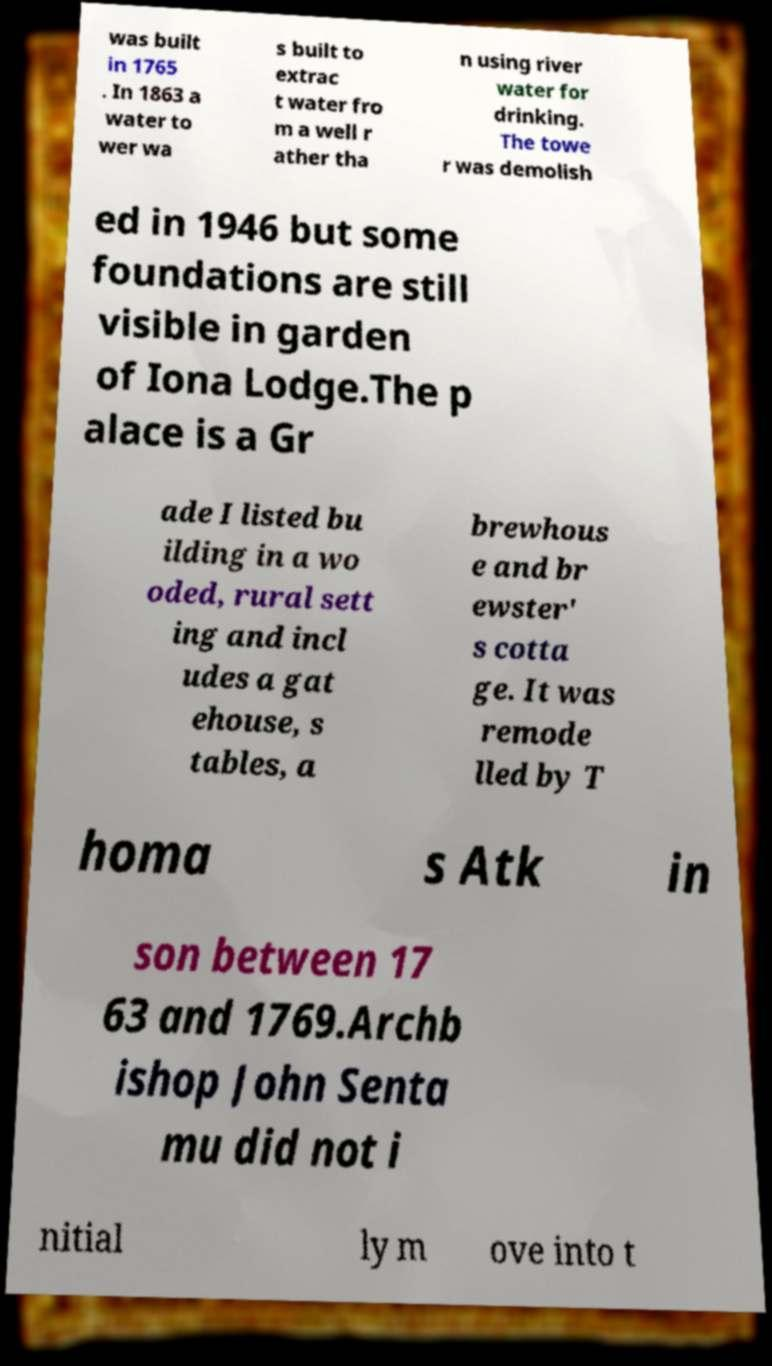There's text embedded in this image that I need extracted. Can you transcribe it verbatim? was built in 1765 . In 1863 a water to wer wa s built to extrac t water fro m a well r ather tha n using river water for drinking. The towe r was demolish ed in 1946 but some foundations are still visible in garden of Iona Lodge.The p alace is a Gr ade I listed bu ilding in a wo oded, rural sett ing and incl udes a gat ehouse, s tables, a brewhous e and br ewster' s cotta ge. It was remode lled by T homa s Atk in son between 17 63 and 1769.Archb ishop John Senta mu did not i nitial ly m ove into t 